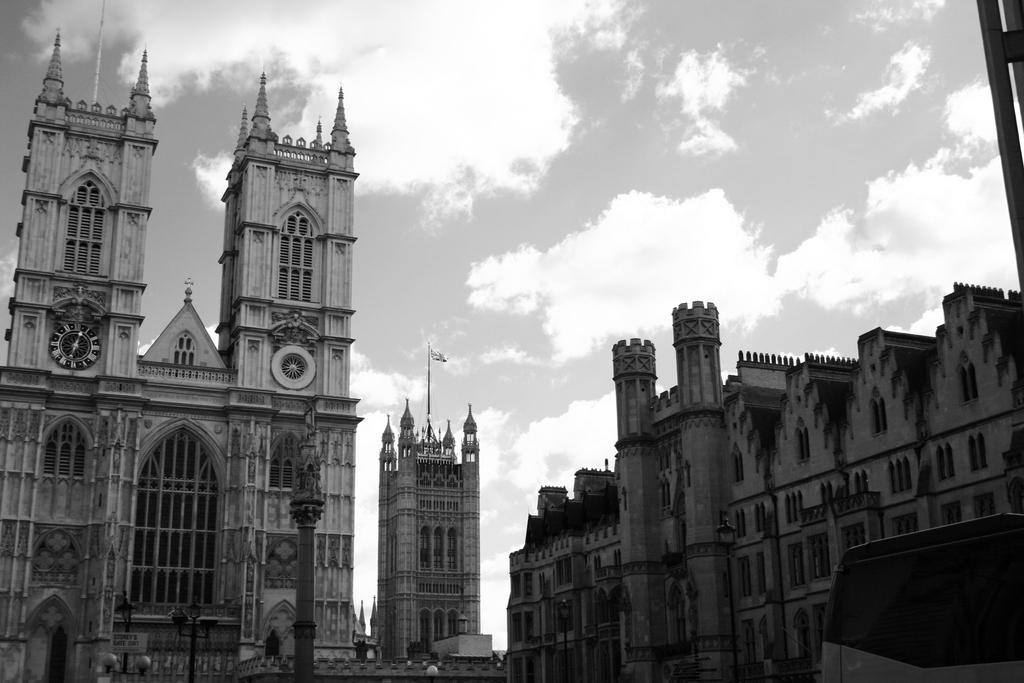Could you give a brief overview of what you see in this image? In this there are buildings. On the left side there is a clock on the pillar of the building and the sky is cloudy. 